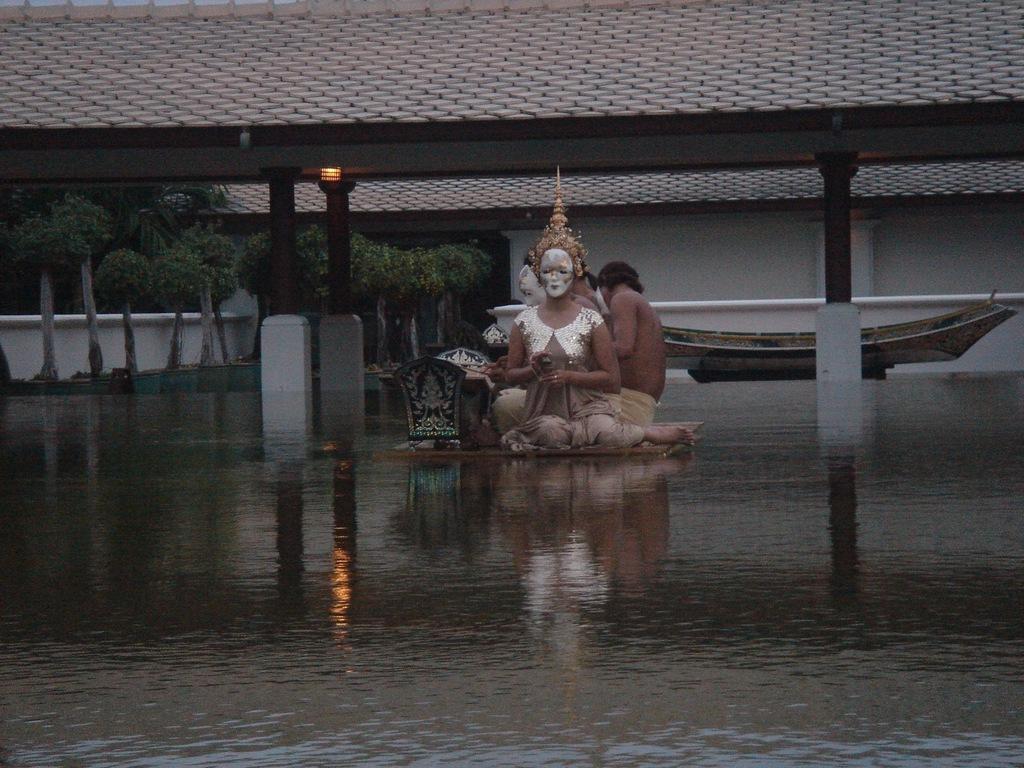Could you give a brief overview of what you see in this image? In this picture I can see the water in front and in the middle of this picture I see few people who are sitting on a thing and I see the shed and I see a light. In the background I see a building and few trees. 